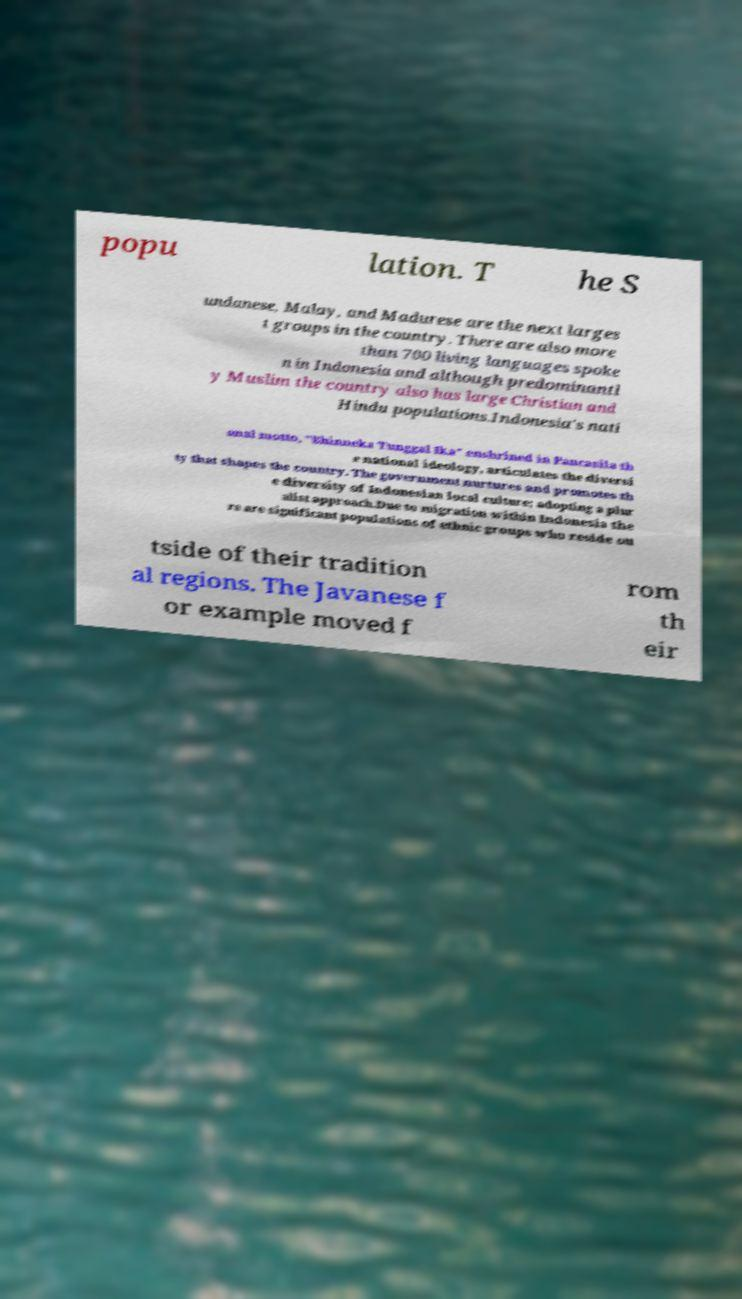What messages or text are displayed in this image? I need them in a readable, typed format. popu lation. T he S undanese, Malay, and Madurese are the next larges t groups in the country. There are also more than 700 living languages spoke n in Indonesia and although predominantl y Muslim the country also has large Christian and Hindu populations.Indonesia's nati onal motto, "Bhinneka Tunggal Ika" enshrined in Pancasila th e national ideology, articulates the diversi ty that shapes the country. The government nurtures and promotes th e diversity of Indonesian local culture; adopting a plur alist approach.Due to migration within Indonesia the re are significant populations of ethnic groups who reside ou tside of their tradition al regions. The Javanese f or example moved f rom th eir 